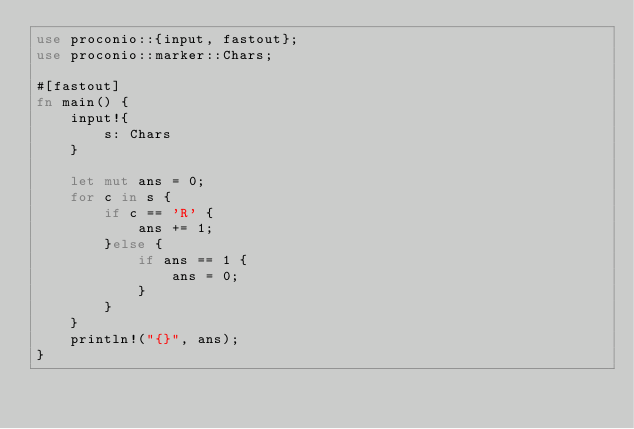Convert code to text. <code><loc_0><loc_0><loc_500><loc_500><_Rust_>use proconio::{input, fastout};
use proconio::marker::Chars;

#[fastout]
fn main() {
    input!{
        s: Chars
    }

    let mut ans = 0;
    for c in s {
        if c == 'R' {
            ans += 1;
        }else {
            if ans == 1 {
                ans = 0;
            }
        }
    }
    println!("{}", ans);
}
</code> 